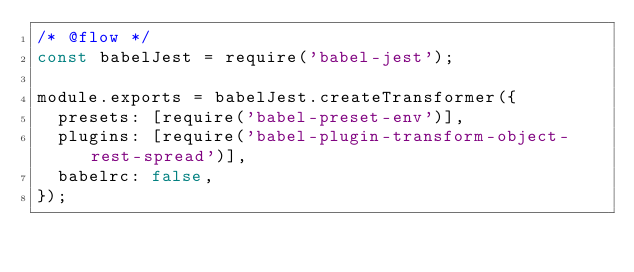<code> <loc_0><loc_0><loc_500><loc_500><_JavaScript_>/* @flow */
const babelJest = require('babel-jest');

module.exports = babelJest.createTransformer({
  presets: [require('babel-preset-env')],
  plugins: [require('babel-plugin-transform-object-rest-spread')],
  babelrc: false,
});
</code> 